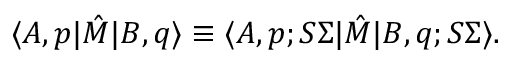<formula> <loc_0><loc_0><loc_500><loc_500>\langle A , p | \hat { M } | B , q \rangle \equiv \langle A , p ; S \Sigma | \hat { M } | B , q ; S \Sigma \rangle .</formula> 